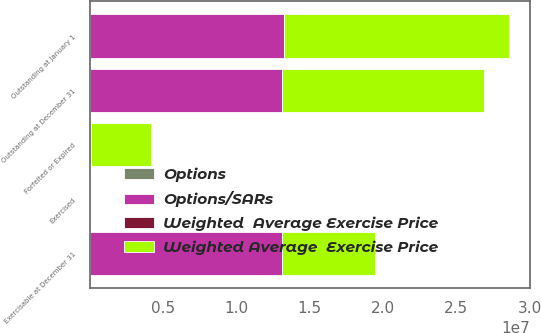<chart> <loc_0><loc_0><loc_500><loc_500><stacked_bar_chart><ecel><fcel>Outstanding at January 1<fcel>Exercised<fcel>Forfeited or Expired<fcel>Outstanding at December 31<fcel>Exercisable at December 31<nl><fcel>Weighted Average  Exercise Price<fcel>1.53843e+07<fcel>38720<fcel>4.09203e+06<fcel>1.38098e+07<fcel>6.34182e+06<nl><fcel>Options<fcel>13.99<fcel>4.56<fcel>21.8<fcel>10.31<fcel>14.55<nl><fcel>Options/SARs<fcel>1.32084e+07<fcel>51751<fcel>73727<fcel>1.30829e+07<fcel>1.30829e+07<nl><fcel>Weighted  Average Exercise Price<fcel>5.66<fcel>5<fcel>6.52<fcel>5.66<fcel>5.66<nl></chart> 